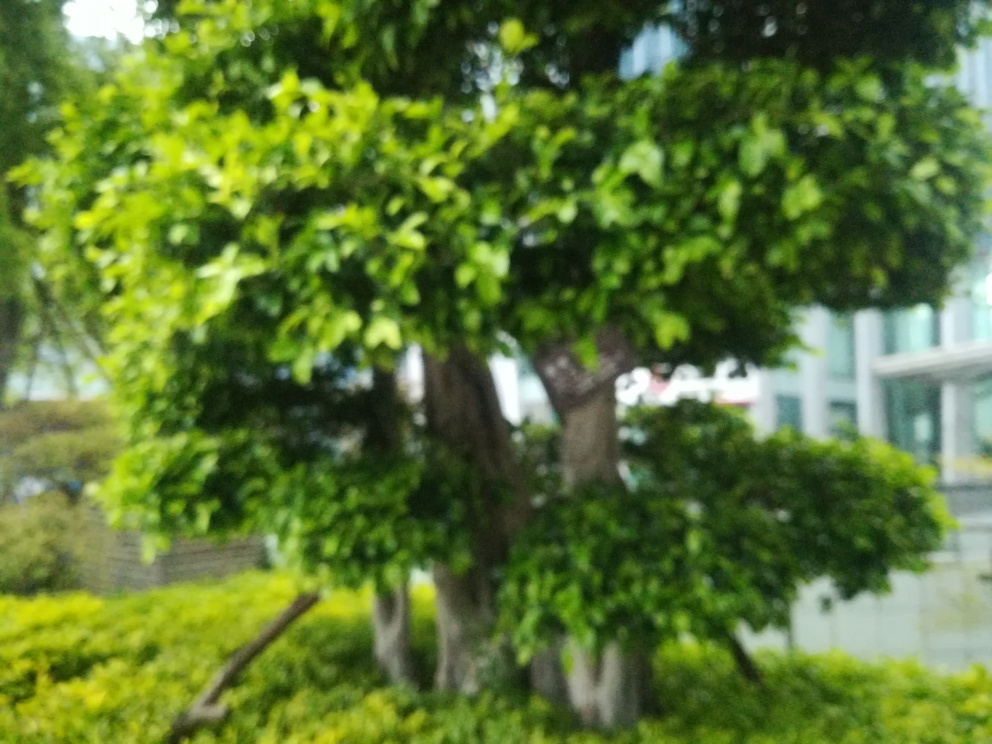Can you tell what time of day it might be in this photo? Despite the lack of focus, the lighting in the photo suggests it might be taken during daylight, likely early in the morning or later in the afternoon when the sunlight isn't as harsh. 